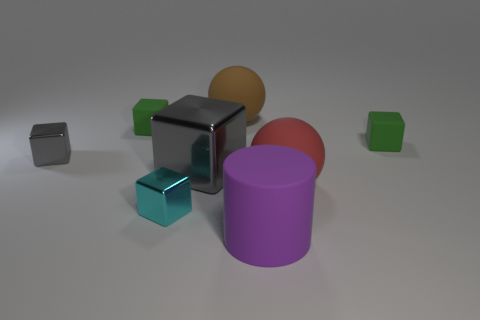Add 2 large yellow metallic cylinders. How many objects exist? 10 Subtract all small cyan metal cubes. How many cubes are left? 4 Subtract all gray cubes. How many cubes are left? 3 Subtract all cylinders. How many objects are left? 7 Subtract 2 spheres. How many spheres are left? 0 Add 1 small cyan matte things. How many small cyan matte things exist? 1 Subtract 0 gray cylinders. How many objects are left? 8 Subtract all gray cylinders. Subtract all red cubes. How many cylinders are left? 1 Subtract all brown cylinders. How many gray blocks are left? 2 Subtract all red rubber balls. Subtract all red spheres. How many objects are left? 6 